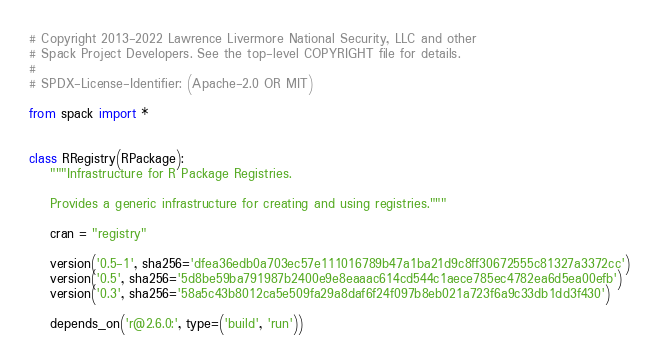Convert code to text. <code><loc_0><loc_0><loc_500><loc_500><_Python_># Copyright 2013-2022 Lawrence Livermore National Security, LLC and other
# Spack Project Developers. See the top-level COPYRIGHT file for details.
#
# SPDX-License-Identifier: (Apache-2.0 OR MIT)

from spack import *


class RRegistry(RPackage):
    """Infrastructure for R Package Registries.

    Provides a generic infrastructure for creating and using registries."""

    cran = "registry"

    version('0.5-1', sha256='dfea36edb0a703ec57e111016789b47a1ba21d9c8ff30672555c81327a3372cc')
    version('0.5', sha256='5d8be59ba791987b2400e9e8eaaac614cd544c1aece785ec4782ea6d5ea00efb')
    version('0.3', sha256='58a5c43b8012ca5e509fa29a8daf6f24f097b8eb021a723f6a9c33db1dd3f430')

    depends_on('r@2.6.0:', type=('build', 'run'))
</code> 